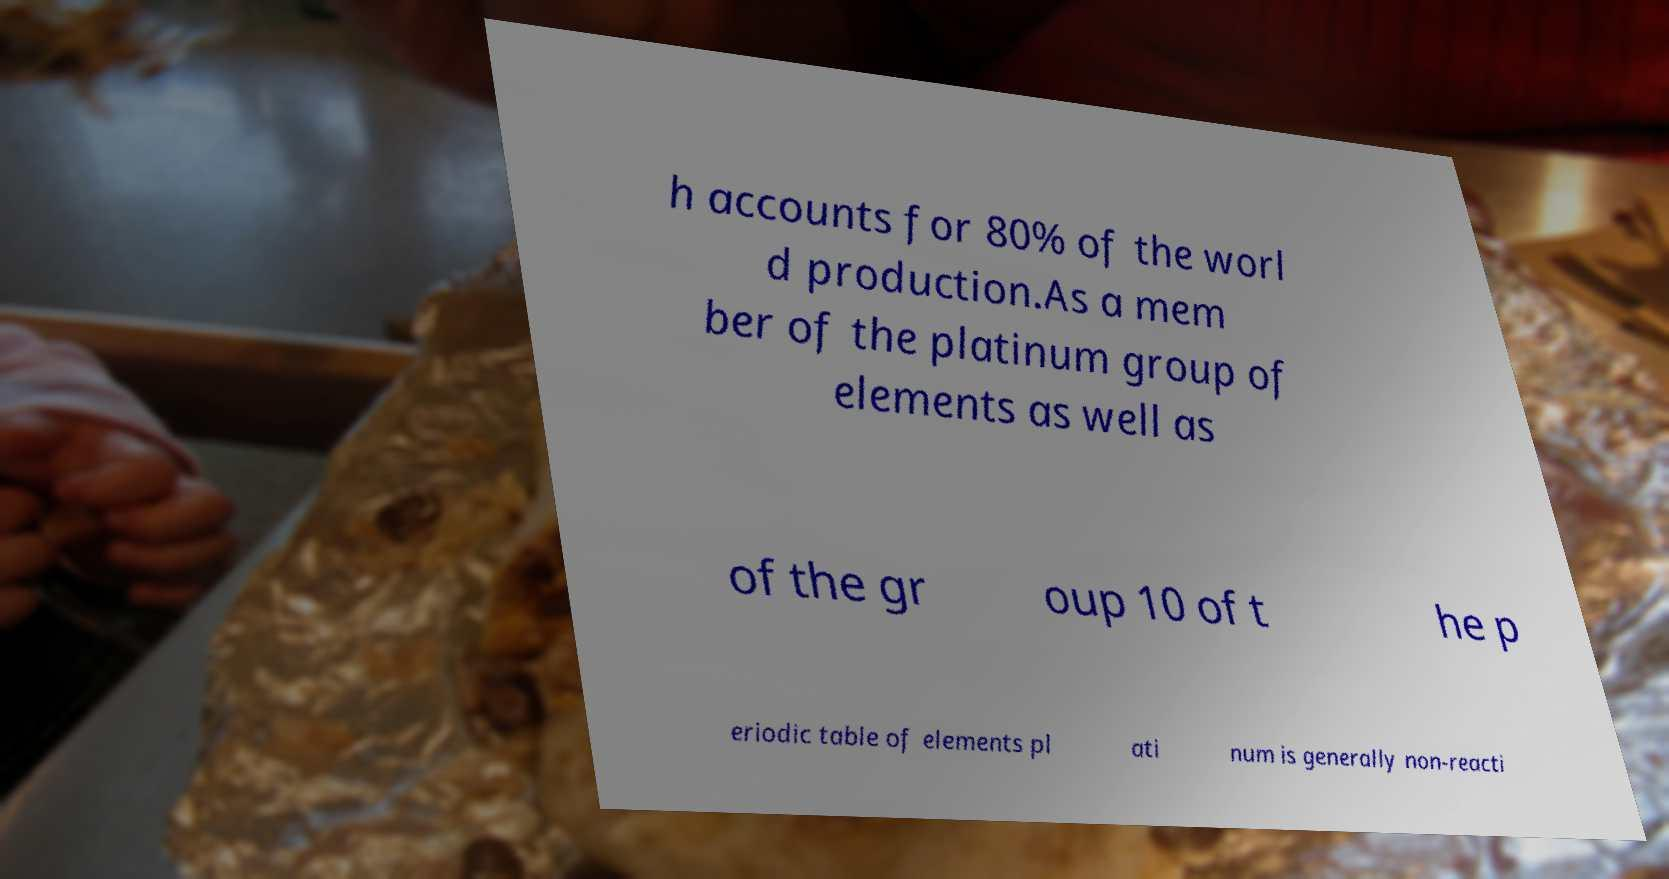What messages or text are displayed in this image? I need them in a readable, typed format. h accounts for 80% of the worl d production.As a mem ber of the platinum group of elements as well as of the gr oup 10 of t he p eriodic table of elements pl ati num is generally non-reacti 